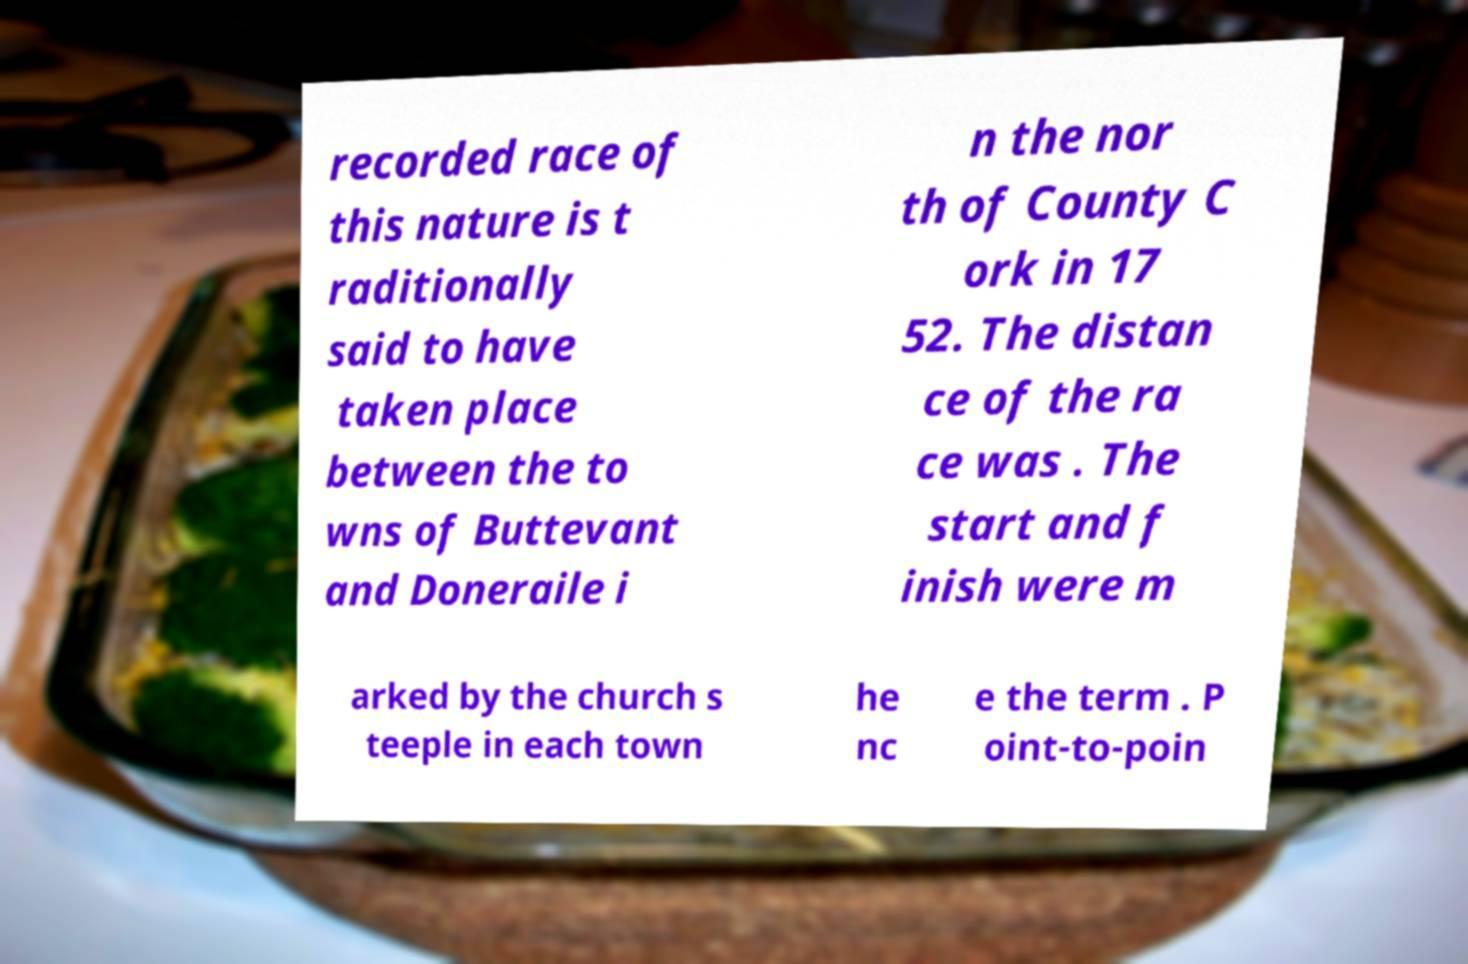For documentation purposes, I need the text within this image transcribed. Could you provide that? recorded race of this nature is t raditionally said to have taken place between the to wns of Buttevant and Doneraile i n the nor th of County C ork in 17 52. The distan ce of the ra ce was . The start and f inish were m arked by the church s teeple in each town he nc e the term . P oint-to-poin 